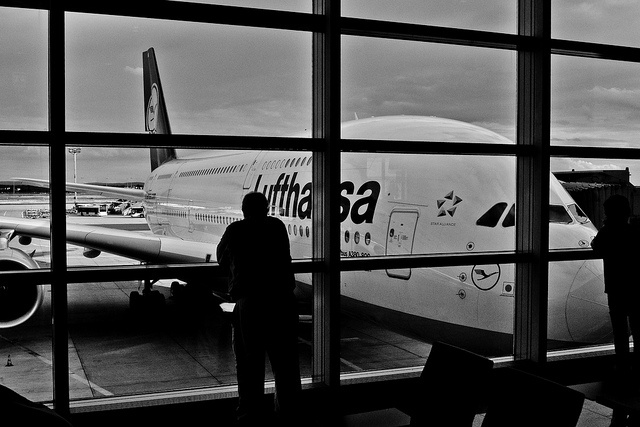Describe the objects in this image and their specific colors. I can see airplane in black, darkgray, gray, and lightgray tones, people in black, gray, darkgray, and lightgray tones, people in black, darkgray, gray, and lightgray tones, and bird in black and gray tones in this image. 